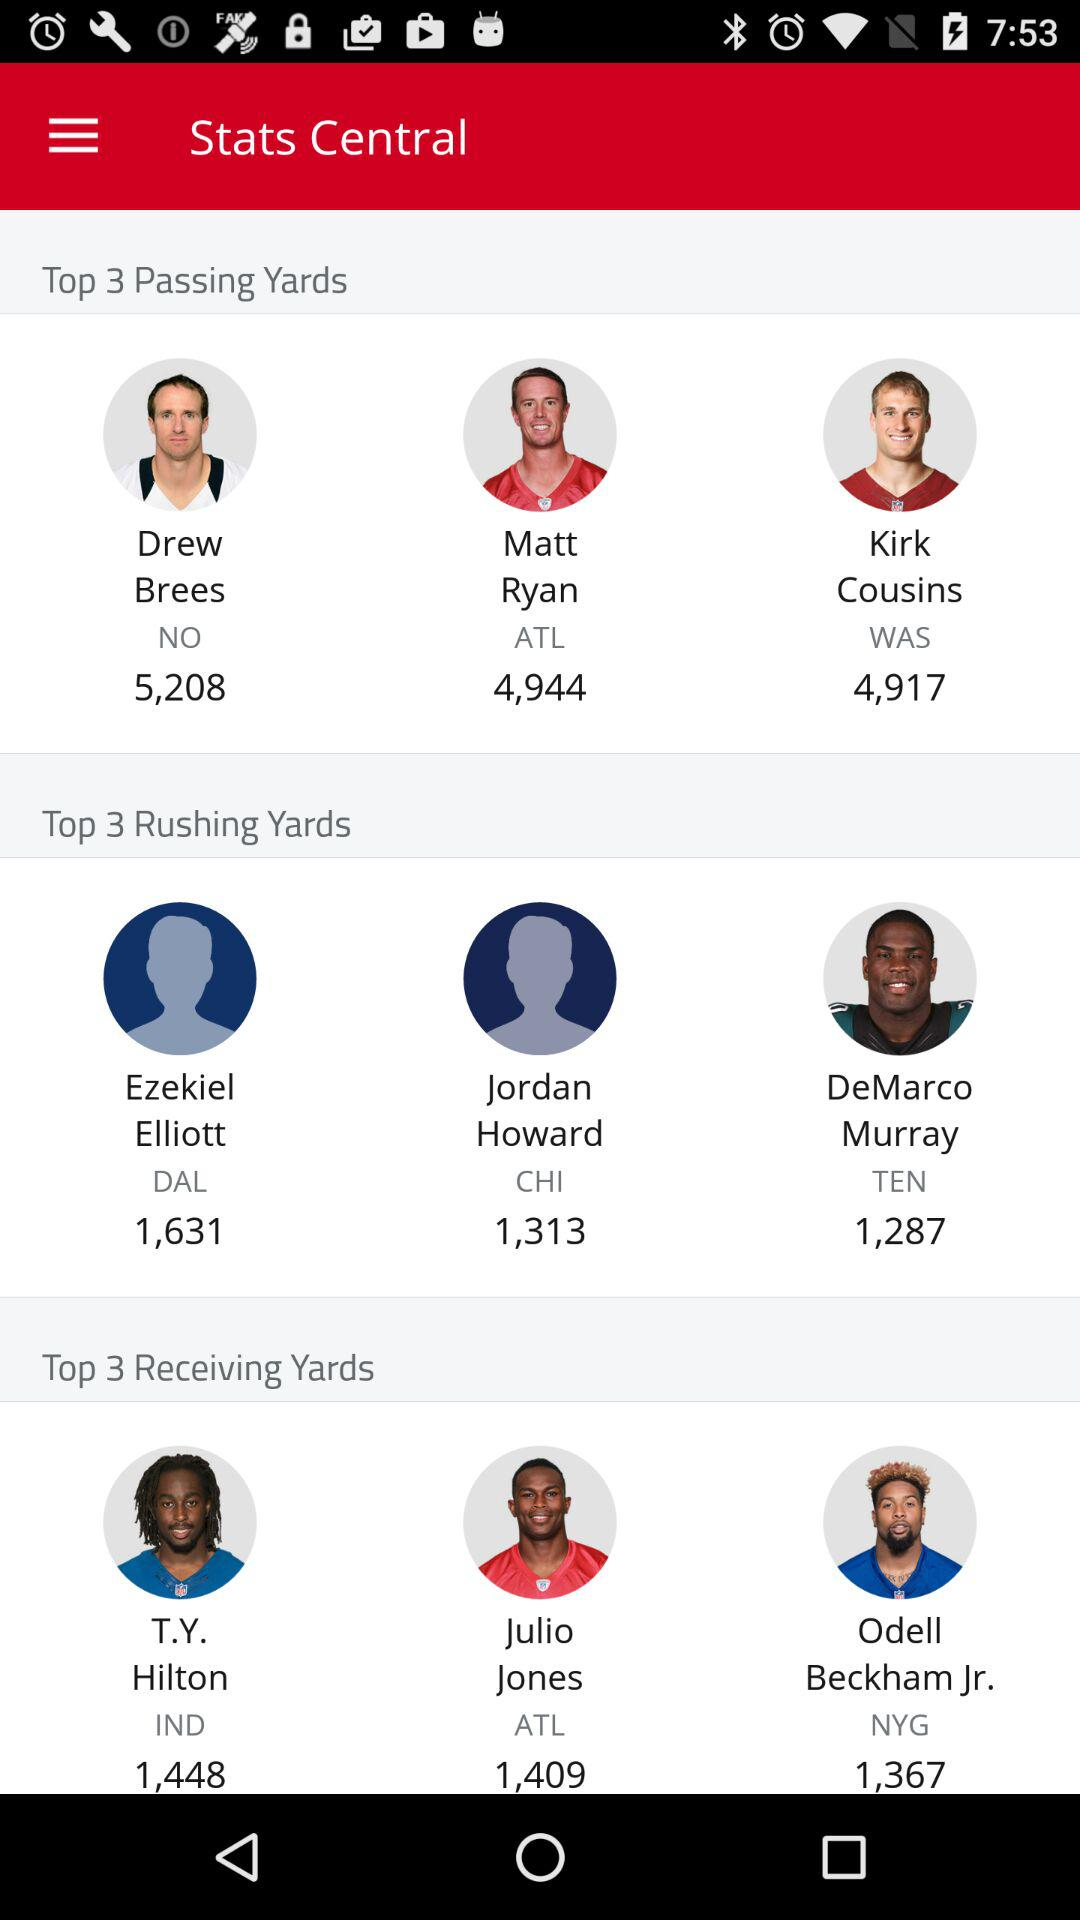What is the team name of Matt Ryan? The team name is "ATL". 